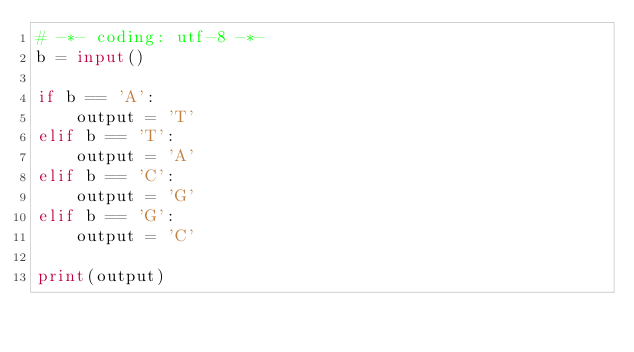Convert code to text. <code><loc_0><loc_0><loc_500><loc_500><_Python_># -*- coding: utf-8 -*-
b = input()

if b == 'A':
    output = 'T'
elif b == 'T':
    output = 'A'
elif b == 'C':
    output = 'G'
elif b == 'G':
    output = 'C'

print(output)</code> 